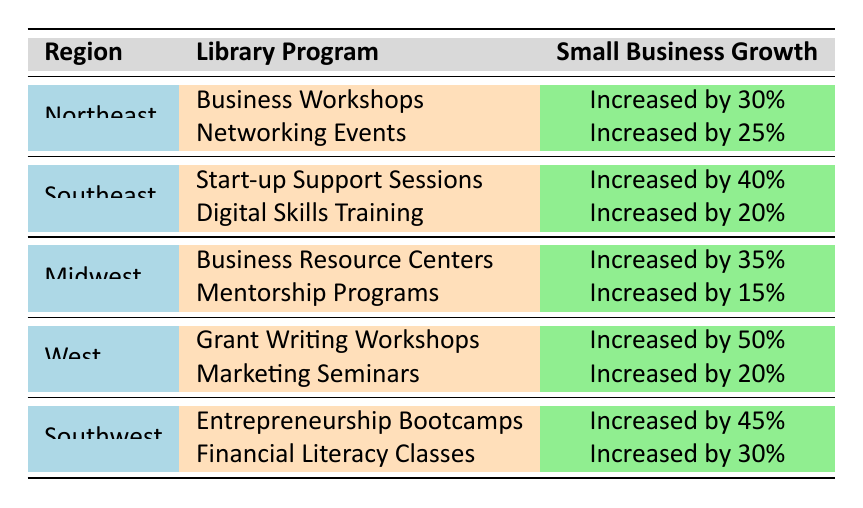What library program in the West region had the highest impact on small business growth? Referring to the table, the "Grant Writing Workshops" in the West region shows "Increased by 50%", which is higher than the other program in the same region.
Answer: Grant Writing Workshops Which region saw the smallest increase in small business growth from library programs? By examining the data, the "Mentorship Programs" in the Midwest region had the smallest increase with "Increased by 15%."
Answer: Midwest What is the total percentage increase in small business growth from library programs in the Southwest region? In the Southwest region, the increases from the "Entrepreneurship Bootcamps" (45%) and "Financial Literacy Classes" (30%) can be summed: 45% + 30% = 75%.
Answer: 75% True or False: The Northeast region had a library program that resulted in a 30% increase in small business growth. The table lists "Business Workshops" in the Northeast region with an increase of "Increased by 30%," confirming the statement is true.
Answer: True Which library program contributed to a greater increase in small business growth: Digital Skills Training or Marketing Seminars? The "Digital Skills Training" in the Southeast region resulted in a 20% increase, while the "Marketing Seminars" in the West region also resulted in a 20% increase, hence both contributed equally.
Answer: Neither What is the average percentage increase in small business growth from the library programs listed for the Northeast? The percentages for the Northeast are 30% (Business Workshops) and 25% (Networking Events). The average is calculated as (30% + 25%) / 2 = 27.5%.
Answer: 27.5% Which region had a library program that led to a higher increase: Southeast's Start-up Support Sessions or Midwest's Business Resource Centers? The Southeast's "Start-up Support Sessions" resulted in an increase of 40%, while the Midwest's "Business Resource Centers" resulted in 35%.
Answer: Southeast Is there any library program listed that led to an increase of 50%? Yes, the table shows that the "Grant Writing Workshops" in the West region resulted in an increase of "Increased by 50%."
Answer: Yes What was the combined impact on small business growth from all the library programs in the Midwest region? The combined impact is the sum of the two programs: "Business Resource Centers" (35%) + "Mentorship Programs" (15%) = 50%.
Answer: 50 